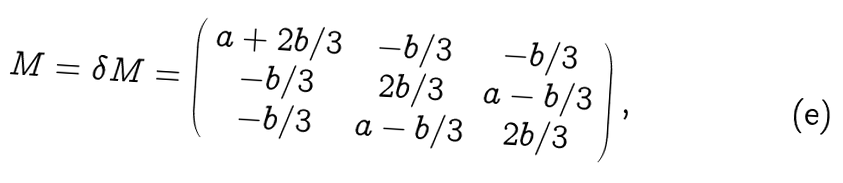Convert formula to latex. <formula><loc_0><loc_0><loc_500><loc_500>M = \delta M = \left ( \begin{array} { c c c } a + 2 b / 3 & - b / 3 & - b / 3 \\ - b / 3 & 2 b / 3 & a - b / 3 \\ - b / 3 & a - b / 3 & 2 b / 3 \end{array} \right ) ,</formula> 